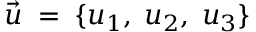Convert formula to latex. <formula><loc_0><loc_0><loc_500><loc_500>\vec { u } \, = \, \{ u _ { 1 } , \, u _ { 2 } , \, u _ { 3 } \}</formula> 